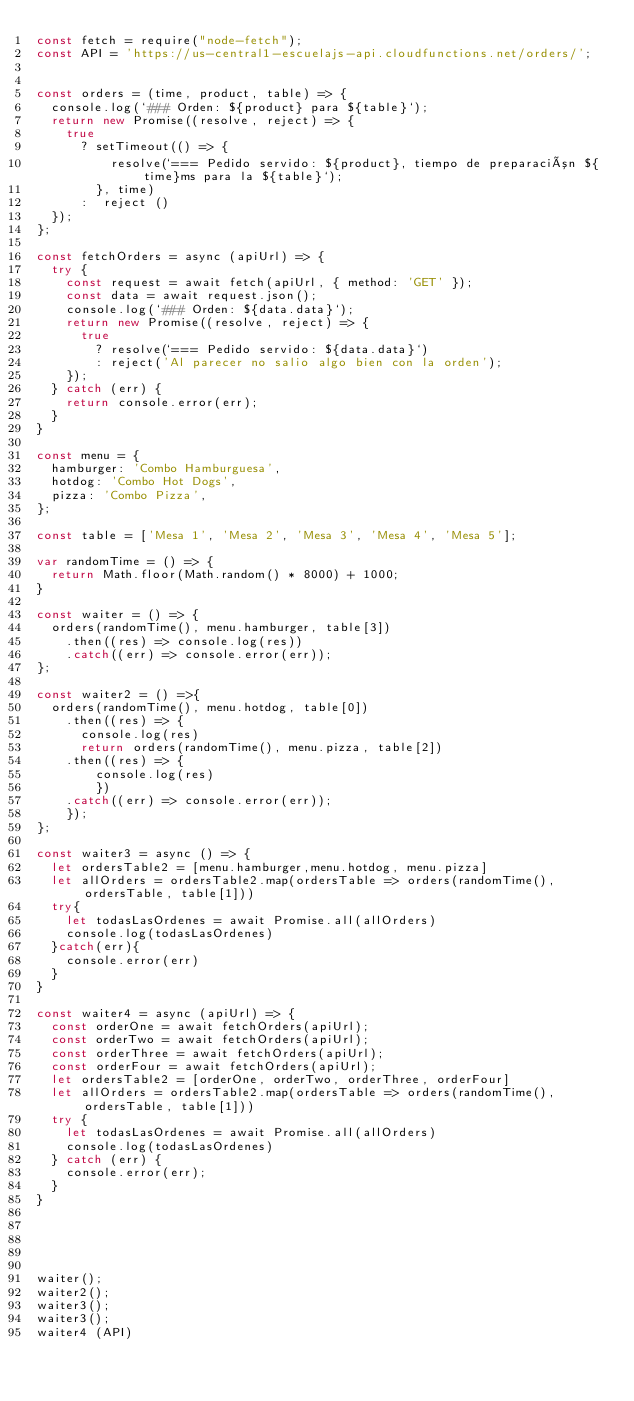<code> <loc_0><loc_0><loc_500><loc_500><_JavaScript_>const fetch = require("node-fetch");
const API = 'https://us-central1-escuelajs-api.cloudfunctions.net/orders/';


const orders = (time, product, table) => {
  console.log(`### Orden: ${product} para ${table}`);
  return new Promise((resolve, reject) => {
    true
      ? setTimeout(() => {
          resolve(`=== Pedido servido: ${product}, tiempo de preparación ${time}ms para la ${table}`);
        }, time)
      :  reject ()
  });
};

const fetchOrders = async (apiUrl) => {
  try {
    const request = await fetch(apiUrl, { method: 'GET' });
    const data = await request.json();
    console.log(`### Orden: ${data.data}`);
    return new Promise((resolve, reject) => {
      true
        ? resolve(`=== Pedido servido: ${data.data}`)
        : reject('Al parecer no salio algo bien con la orden');
    });
  } catch (err) {
    return console.error(err);
  }
}

const menu = {
  hamburger: 'Combo Hamburguesa',
  hotdog: 'Combo Hot Dogs',
  pizza: 'Combo Pizza',
};

const table = ['Mesa 1', 'Mesa 2', 'Mesa 3', 'Mesa 4', 'Mesa 5'];

var randomTime = () => {
  return Math.floor(Math.random() * 8000) + 1000;
}

const waiter = () => {
  orders(randomTime(), menu.hamburger, table[3])
    .then((res) => console.log(res))
    .catch((err) => console.error(err));
};

const waiter2 = () =>{
  orders(randomTime(), menu.hotdog, table[0])
    .then((res) => {
      console.log(res)
      return orders(randomTime(), menu.pizza, table[2])
    .then((res) => {
        console.log(res)
        })
    .catch((err) => console.error(err));
    });
};

const waiter3 = async () => {
  let ordersTable2 = [menu.hamburger,menu.hotdog, menu.pizza]
  let allOrders = ordersTable2.map(ordersTable => orders(randomTime(), ordersTable, table[1]))
  try{
    let todasLasOrdenes = await Promise.all(allOrders)
    console.log(todasLasOrdenes)
  }catch(err){
    console.error(err)
  }
}

const waiter4 = async (apiUrl) => {
  const orderOne = await fetchOrders(apiUrl);
  const orderTwo = await fetchOrders(apiUrl);
  const orderThree = await fetchOrders(apiUrl);
  const orderFour = await fetchOrders(apiUrl);
  let ordersTable2 = [orderOne, orderTwo, orderThree, orderFour]
  let allOrders = ordersTable2.map(ordersTable => orders(randomTime(), ordersTable, table[1]))
  try {
    let todasLasOrdenes = await Promise.all(allOrders)
    console.log(todasLasOrdenes)
  } catch (err) {
    console.error(err);
  }
}





waiter();
waiter2();
waiter3();
waiter3();
waiter4 (API)
</code> 